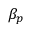Convert formula to latex. <formula><loc_0><loc_0><loc_500><loc_500>\beta _ { p }</formula> 